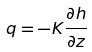Convert formula to latex. <formula><loc_0><loc_0><loc_500><loc_500>q = - K \frac { \partial h } { \partial z }</formula> 